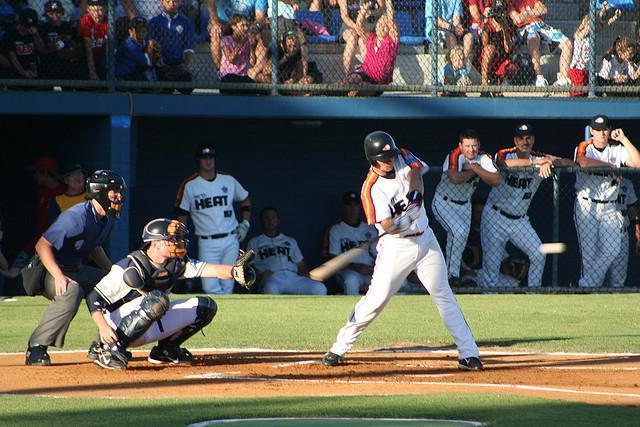How many players are on the fence?
Give a very brief answer. 3. How many people are visible?
Give a very brief answer. 11. How many elephants are in the picture?
Give a very brief answer. 0. 